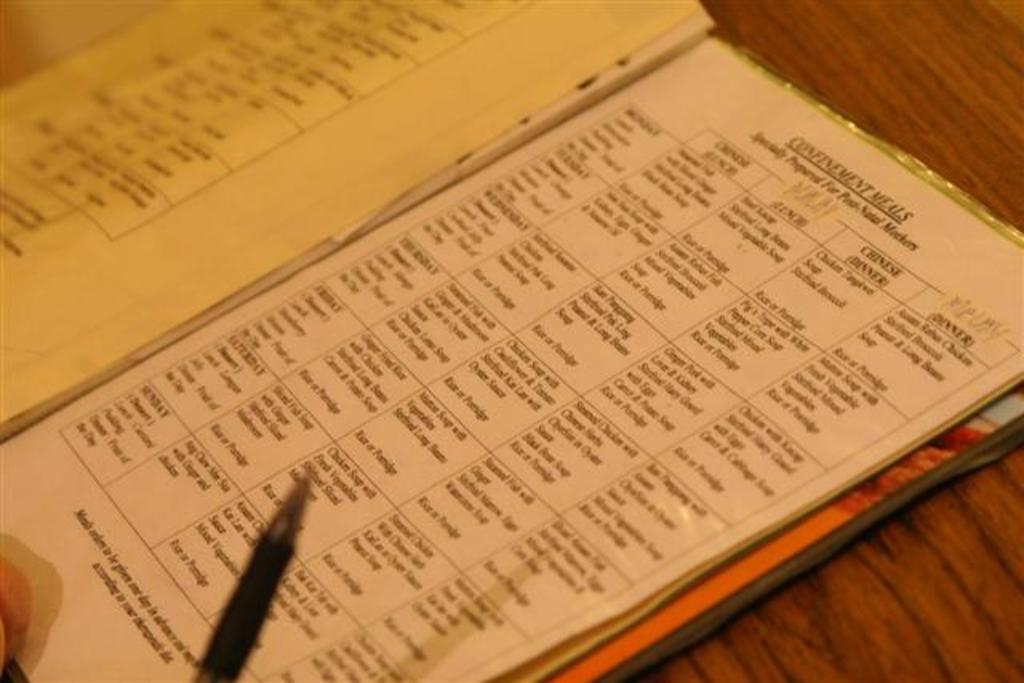<image>
Render a clear and concise summary of the photo. A planner is open to a page that says Confinement Meals. 